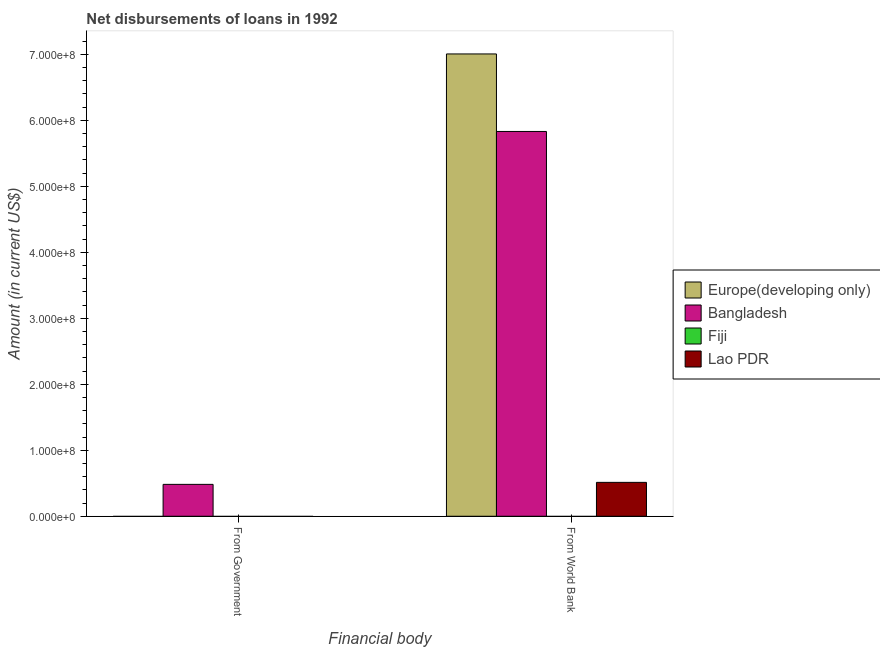Are the number of bars per tick equal to the number of legend labels?
Provide a short and direct response. No. Are the number of bars on each tick of the X-axis equal?
Provide a succinct answer. No. What is the label of the 2nd group of bars from the left?
Your answer should be very brief. From World Bank. What is the net disbursements of loan from government in Lao PDR?
Provide a succinct answer. 0. Across all countries, what is the maximum net disbursements of loan from world bank?
Provide a succinct answer. 7.01e+08. Across all countries, what is the minimum net disbursements of loan from government?
Provide a succinct answer. 0. In which country was the net disbursements of loan from world bank maximum?
Offer a very short reply. Europe(developing only). What is the total net disbursements of loan from world bank in the graph?
Keep it short and to the point. 1.34e+09. What is the difference between the net disbursements of loan from world bank in Europe(developing only) and that in Bangladesh?
Keep it short and to the point. 1.17e+08. What is the difference between the net disbursements of loan from world bank in Europe(developing only) and the net disbursements of loan from government in Bangladesh?
Make the answer very short. 6.52e+08. What is the average net disbursements of loan from world bank per country?
Give a very brief answer. 3.34e+08. What is the difference between the net disbursements of loan from government and net disbursements of loan from world bank in Bangladesh?
Give a very brief answer. -5.35e+08. In how many countries, is the net disbursements of loan from world bank greater than 520000000 US$?
Give a very brief answer. 2. What is the ratio of the net disbursements of loan from world bank in Lao PDR to that in Bangladesh?
Offer a very short reply. 0.09. Is the net disbursements of loan from world bank in Lao PDR less than that in Bangladesh?
Offer a very short reply. Yes. How many bars are there?
Offer a very short reply. 4. What is the difference between two consecutive major ticks on the Y-axis?
Provide a succinct answer. 1.00e+08. Are the values on the major ticks of Y-axis written in scientific E-notation?
Provide a succinct answer. Yes. Does the graph contain any zero values?
Ensure brevity in your answer.  Yes. Does the graph contain grids?
Make the answer very short. No. Where does the legend appear in the graph?
Keep it short and to the point. Center right. What is the title of the graph?
Give a very brief answer. Net disbursements of loans in 1992. What is the label or title of the X-axis?
Your answer should be compact. Financial body. What is the Amount (in current US$) in Europe(developing only) in From Government?
Provide a succinct answer. 0. What is the Amount (in current US$) of Bangladesh in From Government?
Make the answer very short. 4.83e+07. What is the Amount (in current US$) of Fiji in From Government?
Your answer should be compact. 0. What is the Amount (in current US$) of Europe(developing only) in From World Bank?
Your answer should be very brief. 7.01e+08. What is the Amount (in current US$) of Bangladesh in From World Bank?
Offer a very short reply. 5.83e+08. What is the Amount (in current US$) of Lao PDR in From World Bank?
Your answer should be compact. 5.14e+07. Across all Financial body, what is the maximum Amount (in current US$) of Europe(developing only)?
Your response must be concise. 7.01e+08. Across all Financial body, what is the maximum Amount (in current US$) in Bangladesh?
Provide a short and direct response. 5.83e+08. Across all Financial body, what is the maximum Amount (in current US$) in Lao PDR?
Your response must be concise. 5.14e+07. Across all Financial body, what is the minimum Amount (in current US$) of Europe(developing only)?
Give a very brief answer. 0. Across all Financial body, what is the minimum Amount (in current US$) of Bangladesh?
Make the answer very short. 4.83e+07. What is the total Amount (in current US$) in Europe(developing only) in the graph?
Offer a very short reply. 7.01e+08. What is the total Amount (in current US$) in Bangladesh in the graph?
Offer a terse response. 6.32e+08. What is the total Amount (in current US$) in Fiji in the graph?
Your response must be concise. 0. What is the total Amount (in current US$) of Lao PDR in the graph?
Provide a succinct answer. 5.14e+07. What is the difference between the Amount (in current US$) in Bangladesh in From Government and that in From World Bank?
Your answer should be compact. -5.35e+08. What is the difference between the Amount (in current US$) of Bangladesh in From Government and the Amount (in current US$) of Lao PDR in From World Bank?
Your answer should be compact. -3.03e+06. What is the average Amount (in current US$) of Europe(developing only) per Financial body?
Ensure brevity in your answer.  3.50e+08. What is the average Amount (in current US$) in Bangladesh per Financial body?
Make the answer very short. 3.16e+08. What is the average Amount (in current US$) of Fiji per Financial body?
Provide a short and direct response. 0. What is the average Amount (in current US$) of Lao PDR per Financial body?
Offer a very short reply. 2.57e+07. What is the difference between the Amount (in current US$) of Europe(developing only) and Amount (in current US$) of Bangladesh in From World Bank?
Your response must be concise. 1.17e+08. What is the difference between the Amount (in current US$) in Europe(developing only) and Amount (in current US$) in Lao PDR in From World Bank?
Keep it short and to the point. 6.49e+08. What is the difference between the Amount (in current US$) in Bangladesh and Amount (in current US$) in Lao PDR in From World Bank?
Give a very brief answer. 5.32e+08. What is the ratio of the Amount (in current US$) of Bangladesh in From Government to that in From World Bank?
Offer a very short reply. 0.08. What is the difference between the highest and the second highest Amount (in current US$) in Bangladesh?
Your answer should be compact. 5.35e+08. What is the difference between the highest and the lowest Amount (in current US$) of Europe(developing only)?
Your answer should be very brief. 7.01e+08. What is the difference between the highest and the lowest Amount (in current US$) of Bangladesh?
Provide a succinct answer. 5.35e+08. What is the difference between the highest and the lowest Amount (in current US$) in Lao PDR?
Give a very brief answer. 5.14e+07. 